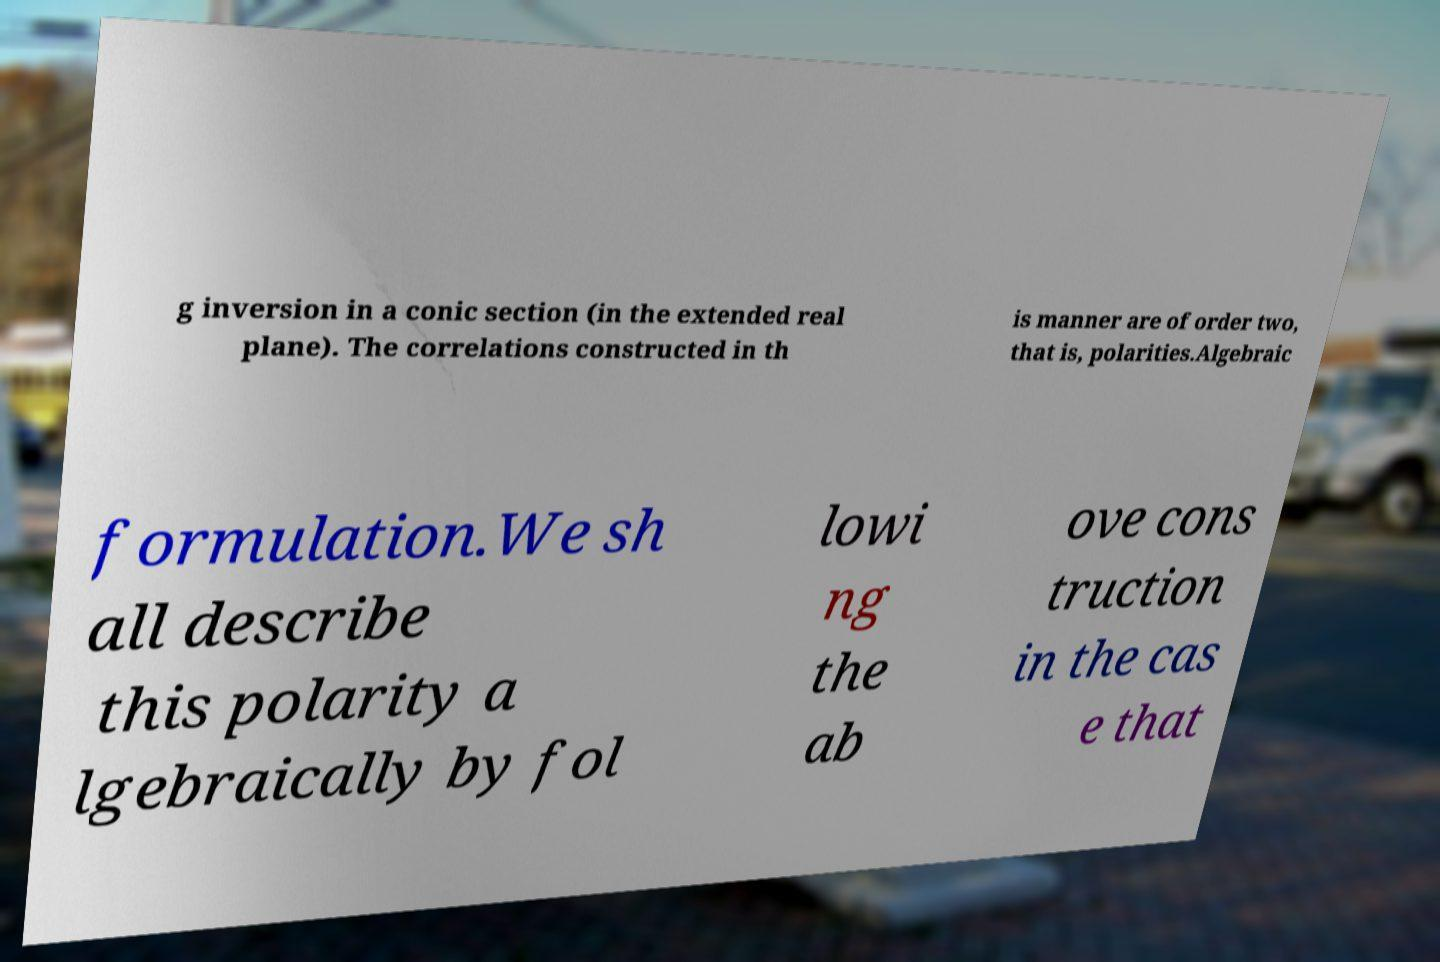Can you read and provide the text displayed in the image?This photo seems to have some interesting text. Can you extract and type it out for me? g inversion in a conic section (in the extended real plane). The correlations constructed in th is manner are of order two, that is, polarities.Algebraic formulation.We sh all describe this polarity a lgebraically by fol lowi ng the ab ove cons truction in the cas e that 